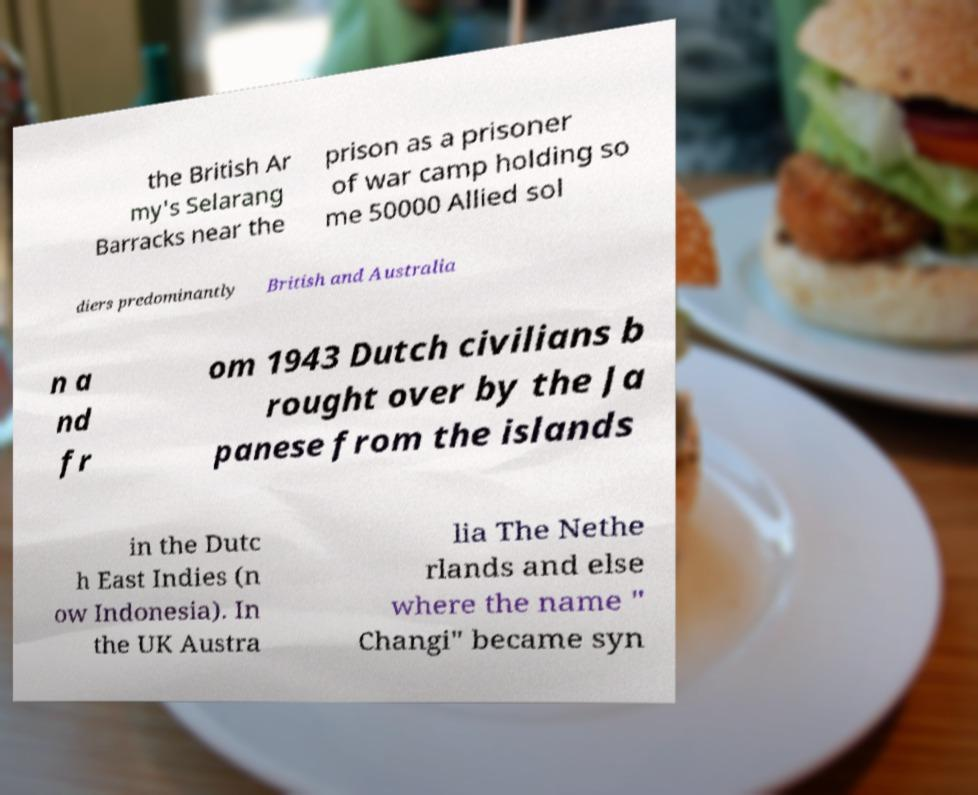I need the written content from this picture converted into text. Can you do that? the British Ar my's Selarang Barracks near the prison as a prisoner of war camp holding so me 50000 Allied sol diers predominantly British and Australia n a nd fr om 1943 Dutch civilians b rought over by the Ja panese from the islands in the Dutc h East Indies (n ow Indonesia). In the UK Austra lia The Nethe rlands and else where the name " Changi" became syn 